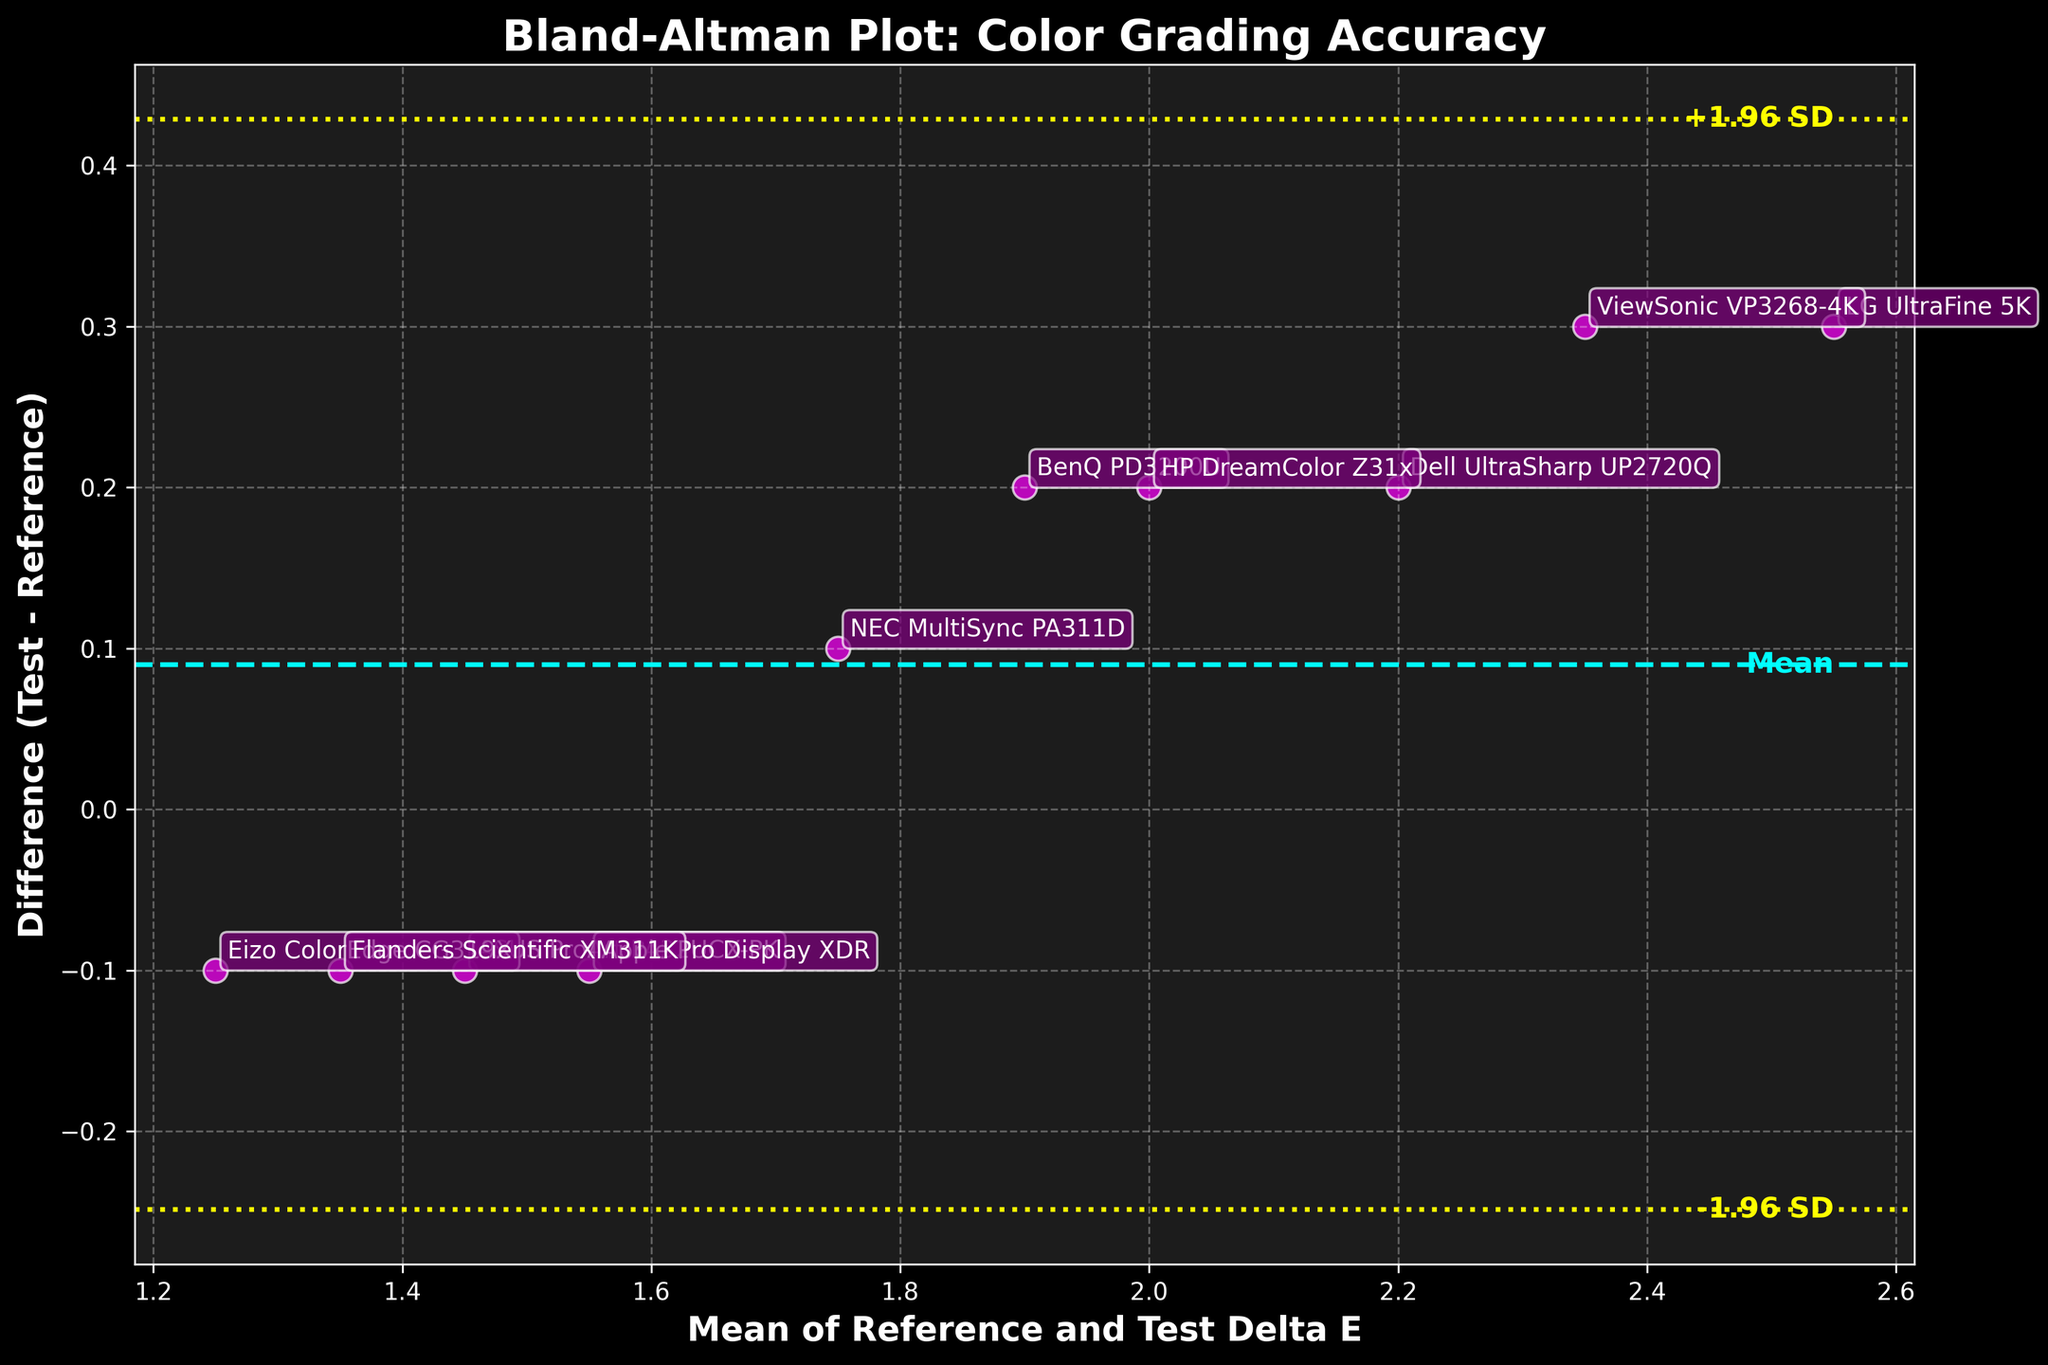How many data points are present in the plot? The plot displays data as individual scatter points. By counting these points, we see that there are 10 of them.
Answer: 10 What color are the scatter points and what is their distinguishing feature? The scatter points are magenta in color, with each point labeled with the respective monitor model. Additionally, they have a white edge.
Answer: Magenta with white edges and labeled What is the overall title of the figure and what do the axes represent? The title of the figure is "Bland-Altman Plot: Color Grading Accuracy". The x-axis represents the "Mean of Reference and Test Delta E", and the y-axis represents the "Difference (Test - Reference)".
Answer: "Bland-Altman Plot: Color Grading Accuracy", x-axis: "Mean of Reference and Test Delta E", y-axis: "Difference (Test - Reference)" What are the colors and meanings of the horizontal lines in the plot? The plot has three horizontal lines: the dashed cyan line represents the mean difference, and the two dotted yellow lines represent the limits of agreement (-1.96 SD and +1.96 SD).
Answer: Cyan: mean difference, Yellow: limits of agreement What is the approximate range of the y-axis values? The y-axis represents the difference (Test - Reference), and from the plot, the range appears to be from -0.2 to 0.6.
Answer: -0.2 to 0.6 Which monitor model shows the highest positive difference between Test and Reference Delta E values? By observing the scatter points and their labels, the monitor model "LG UltraFine 5K" appears to have the highest positive difference.
Answer: LG UltraFine 5K What are the calculated limits of agreement and how are they represented on the plot? The limits of agreement are the range within which 95% of the differences between test and reference measurements lie. They are represented by the yellow dotted lines on the plot.
Answer: Two yellow dotted lines What does the position of the Dell UltraSharp UP2720Q point tell you about the monitor's color grading accuracy compared to the reference? The Dell UltraSharp UP2720Q point is above the mean difference line, indicating that it has a positive difference, meaning the Test Delta E value is slightly higher than the Reference Delta E value.
Answer: Test value is higher than Reference How are outliers identified in the Bland-Altman plot, and which monitors, if any, are outliers based on the current plot data? Outliers in a Bland-Altman plot are points that lie outside the limits of agreement. From the plot, none of the monitors appear to be outliers as all points are within the yellow dotted lines.
Answer: No outliers 